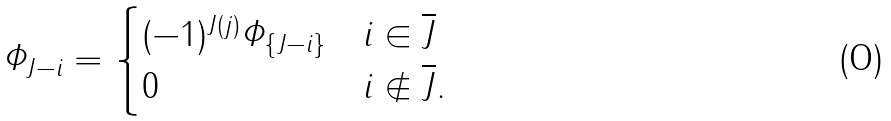Convert formula to latex. <formula><loc_0><loc_0><loc_500><loc_500>\varPhi _ { J - i } = \begin{cases} ( - 1 ) ^ { J ( j ) } \varPhi _ { \{ J - i \} } & i \in \overline { J } \\ 0 & i \notin \overline { J } . \end{cases}</formula> 